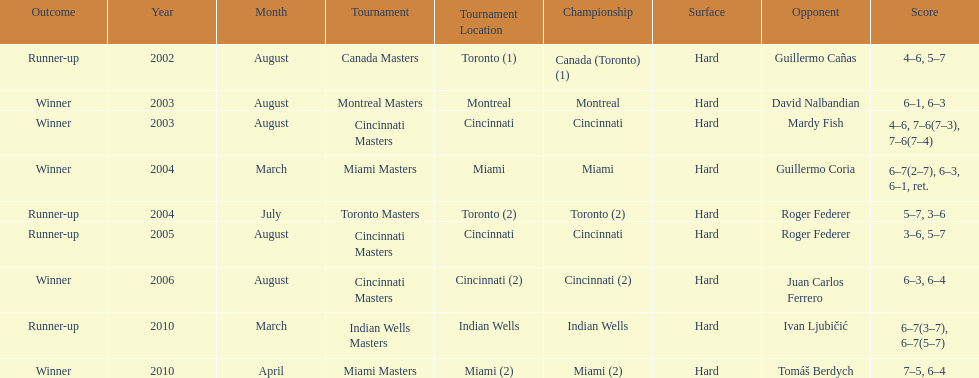Was roddick a runner-up or winner more? Winner. 